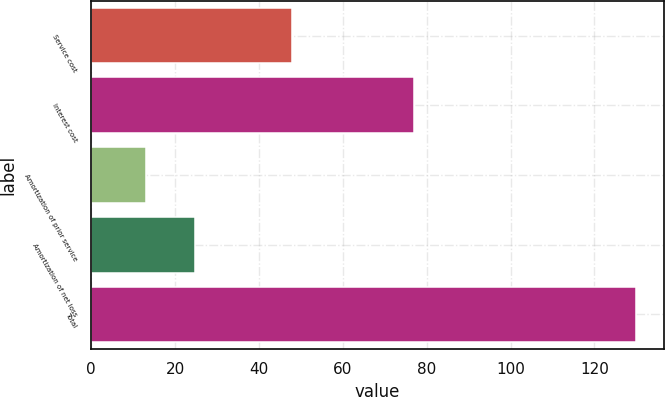<chart> <loc_0><loc_0><loc_500><loc_500><bar_chart><fcel>Service cost<fcel>Interest cost<fcel>Amortization of prior service<fcel>Amortization of net loss<fcel>Total<nl><fcel>48<fcel>77<fcel>13<fcel>24.7<fcel>130<nl></chart> 